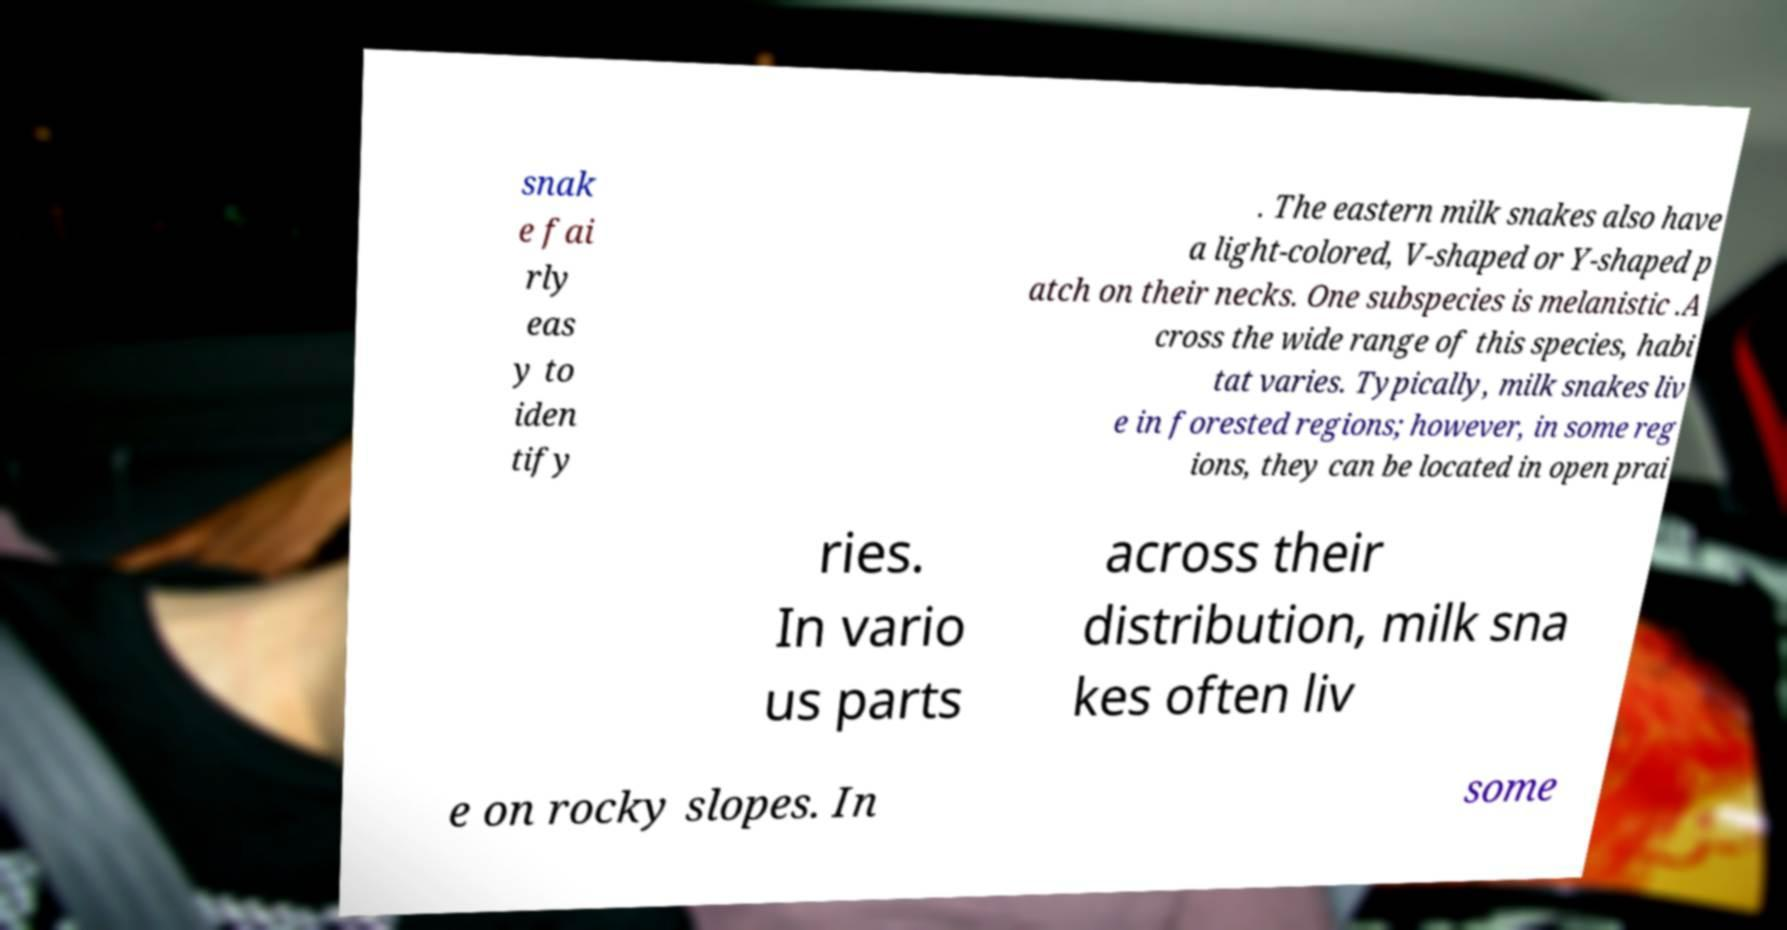Please identify and transcribe the text found in this image. snak e fai rly eas y to iden tify . The eastern milk snakes also have a light-colored, V-shaped or Y-shaped p atch on their necks. One subspecies is melanistic .A cross the wide range of this species, habi tat varies. Typically, milk snakes liv e in forested regions; however, in some reg ions, they can be located in open prai ries. In vario us parts across their distribution, milk sna kes often liv e on rocky slopes. In some 